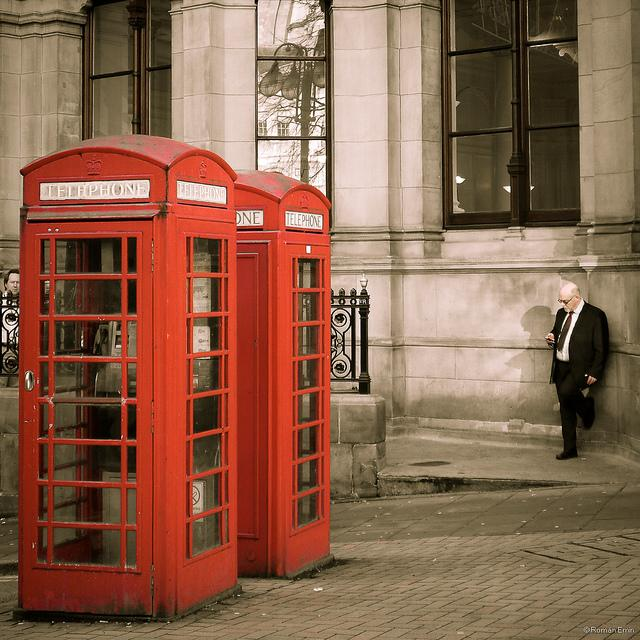If the gentleman here in the suit wants to call his sweetheart where will he do it?

Choices:
A) inside building
B) phone booth
C) taxi
D) standing there phone booth 